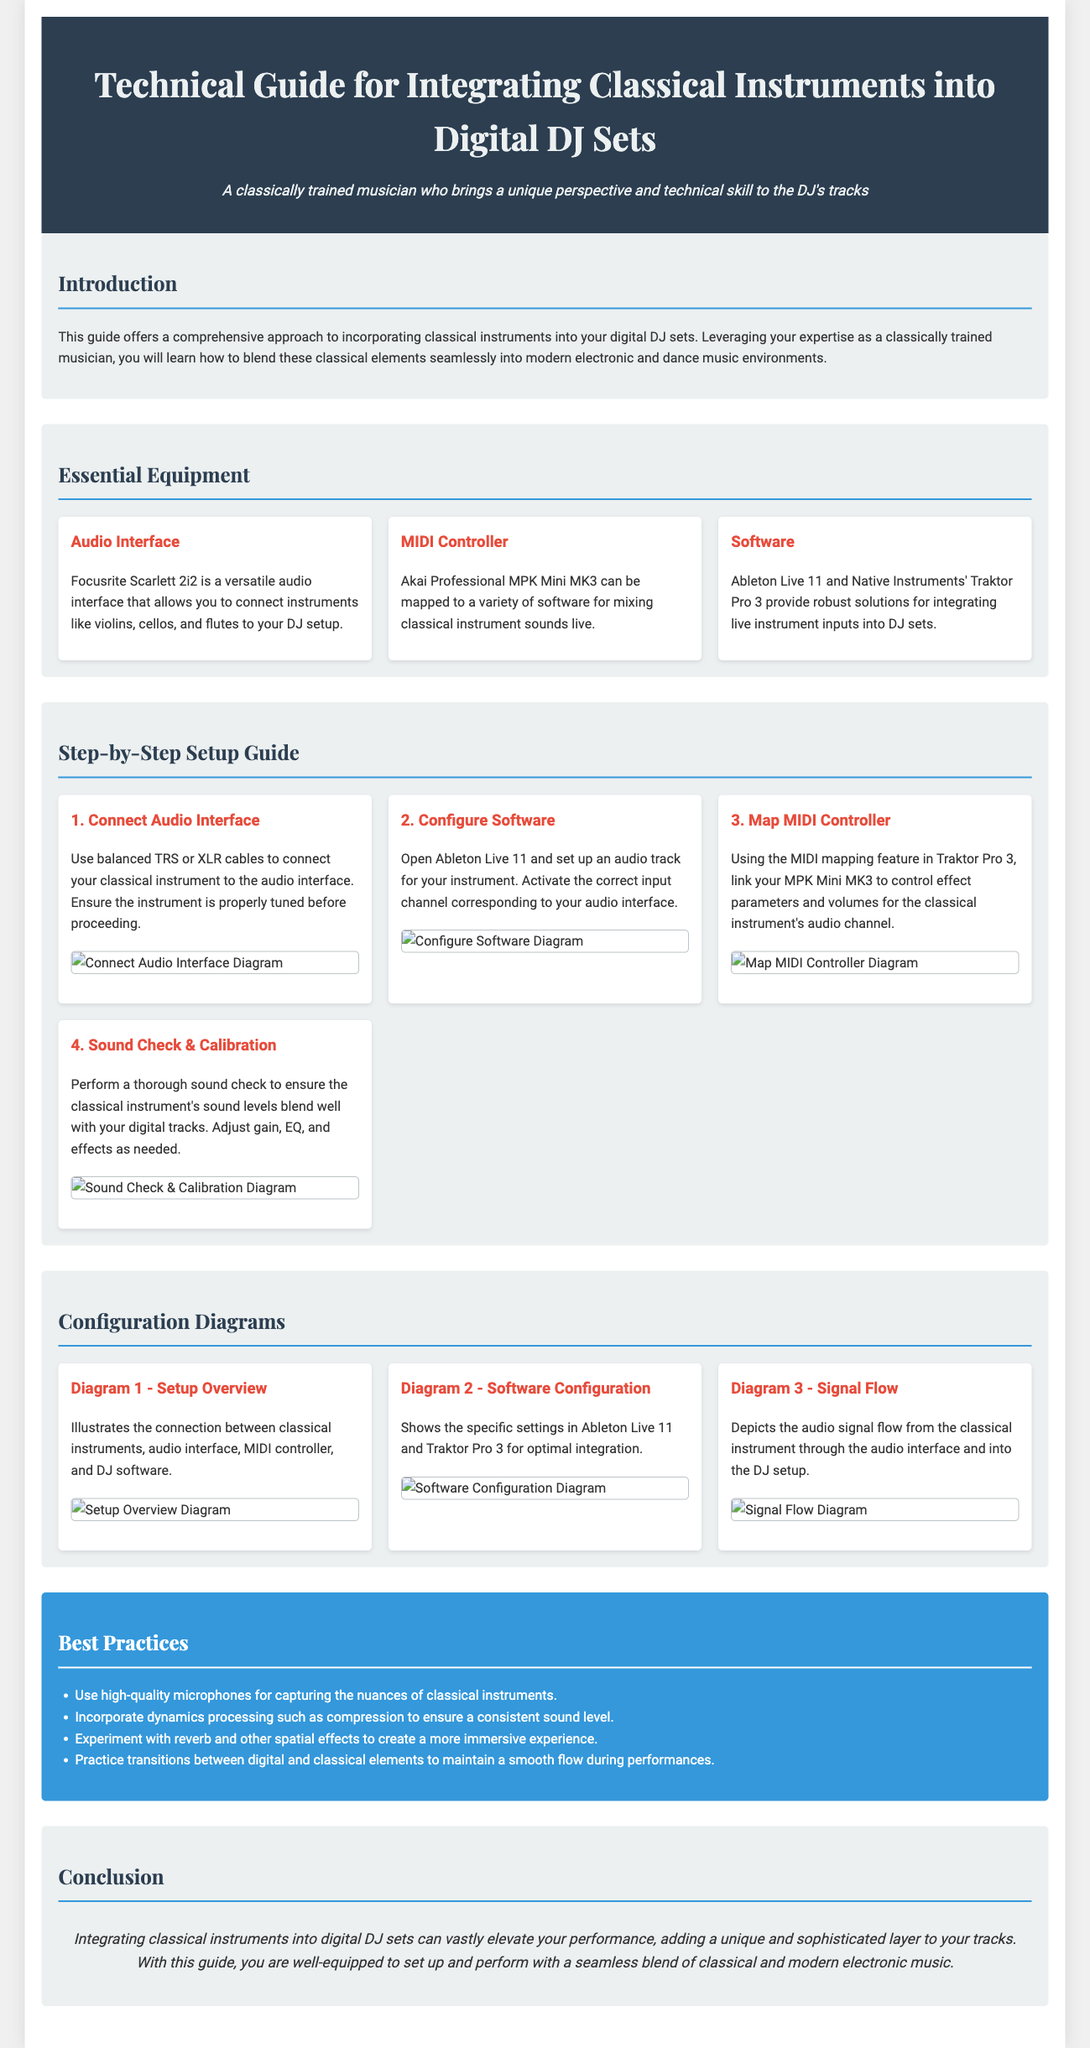What is the name of the audio interface suggested in the guide? The audio interface suggested is the Focusrite Scarlett 2i2, which allows connecting classical instruments to the DJ setup.
Answer: Focusrite Scarlett 2i2 What software is mentioned for integrating live instrument inputs? The software mentioned for integrating live instrument inputs is Ableton Live 11 and Traktor Pro 3.
Answer: Ableton Live 11 and Traktor Pro 3 How many steps are outlined in the step-by-step setup guide? There are four steps outlined in the step-by-step setup guide for incorporating classical instruments into DJ sets.
Answer: Four What is the main purpose of the guide? The main purpose of the guide is to offer a comprehensive approach to incorporating classical instruments into digital DJ sets.
Answer: Incorporating classical instruments into digital DJ sets What is the first step in the setup process? The first step in the setup process is to connect the audio interface using balanced TRS or XLR cables.
Answer: Connect Audio Interface Which instrument is specifically mentioned for connection in the guide? Instruments like violins, cellos, and flutes are specifically mentioned for connection to the DJ setup.
Answer: Violins, cellos, and flutes What color is used for the section headers in the best practices? The section headers in the best practices are colored white text on a blue background.
Answer: White What is a recommended practice for capturing sound from classical instruments? A recommended practice is to use high-quality microphones for capturing the nuances of classical instruments.
Answer: High-quality microphones 